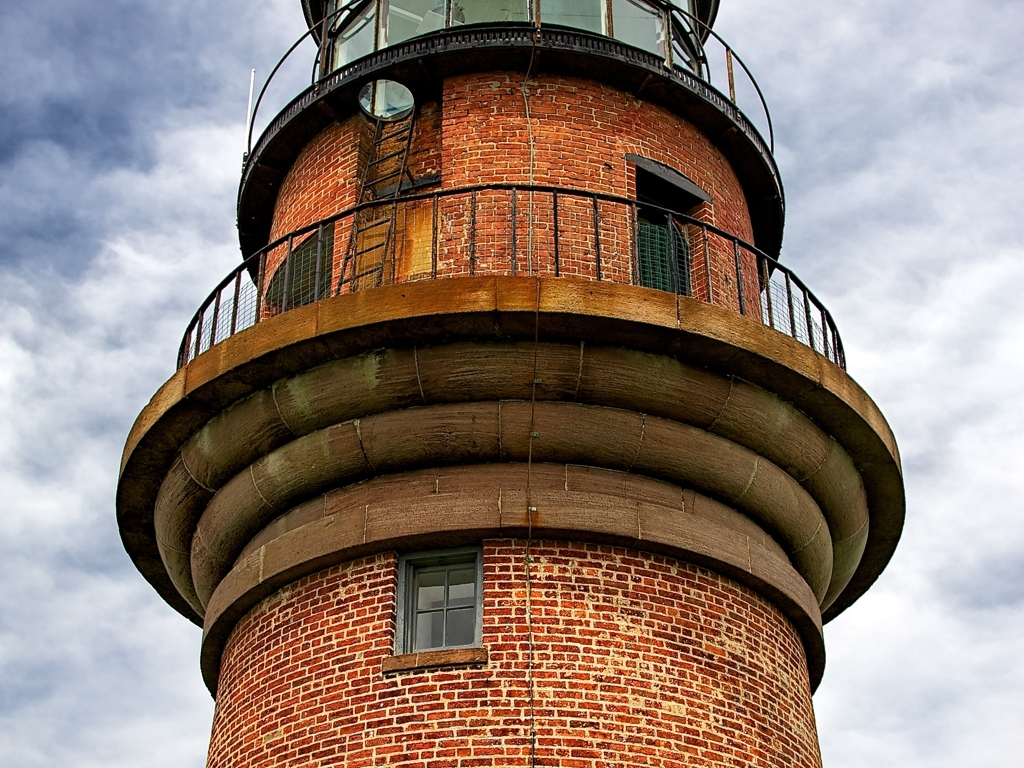Can you tell me more about what this structure is used for? Sure! The structure in the image appears to be a lighthouse, which is traditionally used for navigation by maritime pilots at sea or on inland waterways. Its purpose is to mark dangerous coastlines, hazardous shoals, reefs, rocks, and to indicate safe entry points to harbors. The design and brickwork suggest it's quite old and may now serve more as a historical monument or a local landmark rather than an active navigation aid. 